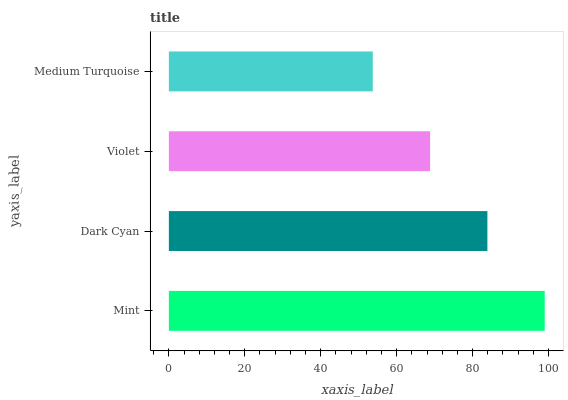Is Medium Turquoise the minimum?
Answer yes or no. Yes. Is Mint the maximum?
Answer yes or no. Yes. Is Dark Cyan the minimum?
Answer yes or no. No. Is Dark Cyan the maximum?
Answer yes or no. No. Is Mint greater than Dark Cyan?
Answer yes or no. Yes. Is Dark Cyan less than Mint?
Answer yes or no. Yes. Is Dark Cyan greater than Mint?
Answer yes or no. No. Is Mint less than Dark Cyan?
Answer yes or no. No. Is Dark Cyan the high median?
Answer yes or no. Yes. Is Violet the low median?
Answer yes or no. Yes. Is Mint the high median?
Answer yes or no. No. Is Medium Turquoise the low median?
Answer yes or no. No. 